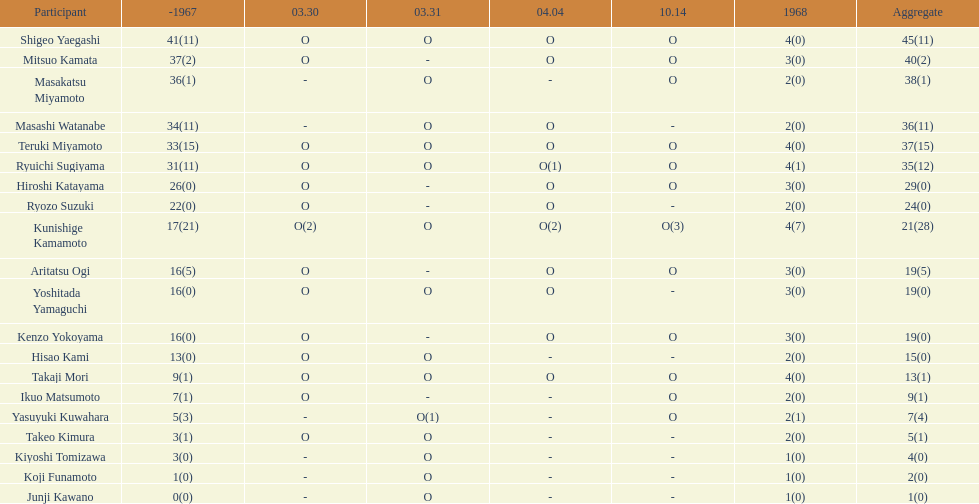How many players made an appearance that year? 20. 